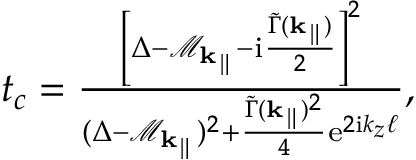<formula> <loc_0><loc_0><loc_500><loc_500>\begin{array} { r } { t _ { c } = \frac { \left [ \Delta - \mathcal { M } _ { k _ { \| } } - i \frac { \widetilde { \Gamma } ( { k _ { \| } } ) } { 2 } \right ] ^ { 2 } } { ( \Delta - \mathcal { M } _ { k _ { \| } } ) ^ { 2 } + \frac { \widetilde { \Gamma } ( { k _ { \| } } ) ^ { 2 } } { 4 } e ^ { 2 i k _ { z } \ell } } , } \end{array}</formula> 